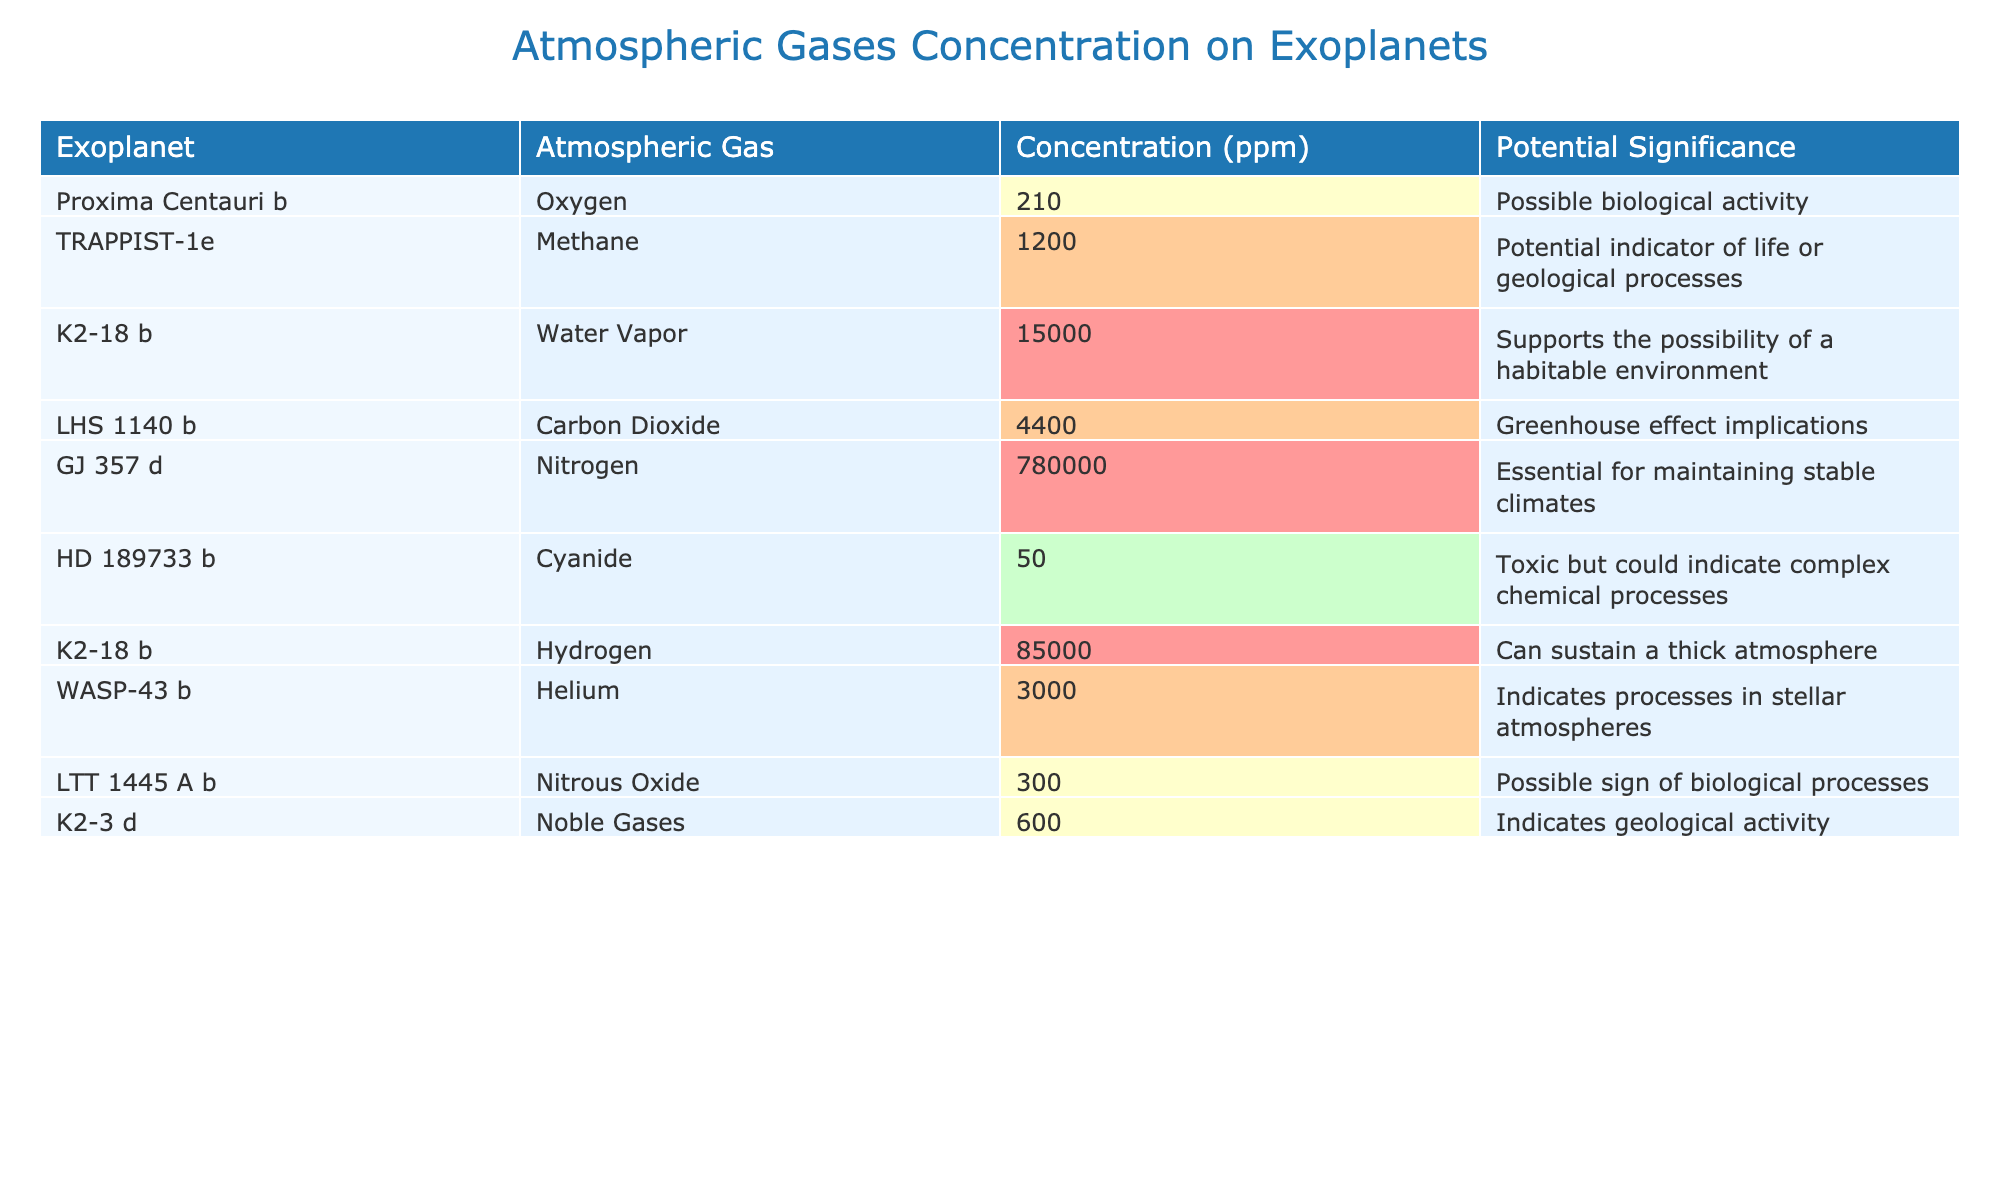What is the concentration of Oxygen on Proxima Centauri b? The table lists the atmospheric gas concentration for each exoplanet. Proxima Centauri b has an Oxygen concentration of 210 ppm.
Answer: 210 ppm Which exoplanet has the highest concentration of Water Vapor? The table indicates that K2-18 b has a Water Vapor concentration of 15,000 ppm, which is more than any other exoplanet listed.
Answer: K2-18 b Is the concentration of Carbon Dioxide on LHS 1140 b greater than 4000 ppm? The table shows that LHS 1140 b has a Carbon Dioxide concentration of 4,400 ppm, which is indeed greater than 4,000 ppm.
Answer: Yes What is the sum of the concentrations of Nitrogen and Nitrous Oxide? From the table, Nitrogen on GJ 357 d is 780,000 ppm and Nitrous Oxide on LTT 1445 A b is 300 ppm. So, 780,000 + 300 = 780,300 ppm.
Answer: 780300 ppm How many exoplanets have a concentration of Methane over 1,000 ppm? The only exoplanet with Methane concentration over 1,000 ppm listed is TRAPPIST-1e, which has a concentration of 1,200 ppm, making a total of one exoplanet.
Answer: 1 Which atmospheric gas shows a potential indicator of biological processes? The table highlights two gases linked with potential biological processes: Nitrous Oxide on LTT 1445 A b and Methane on TRAPPIST-1e.
Answer: Nitrous Oxide and Methane What is the average concentration of gases that could suggest biological activity? Biological activity indicators are Oxygen (210 ppm), Methane (1,200 ppm), and Nitrous Oxide (300 ppm). Average calculation is (210 + 1200 + 300) / 3 = 570 ppm.
Answer: 570 ppm Which exoplanet has the lowest concentration of Cyanide, and what is its value? According to the table, HD 189733 b has a Cyanide concentration of 50 ppm, which is lower than any other entry for Cyanide.
Answer: HD 189733 b, 50 ppm Which gases have concentrations above 1,000 ppm and are linked to possible signs of life? The table indicates that Methane (1,200 ppm) and Water Vapor (15,000 ppm) fit this criterion, as both concentrations are above 1,000 ppm and have potential life indicators.
Answer: Methane and Water Vapor Is there an exoplanet where the concentration of Hydrogen exceeds 80,000 ppm? Yes, according to the table, K2-18 b has a Hydrogen concentration of 85,000 ppm, which exceeds 80,000 ppm.
Answer: Yes 